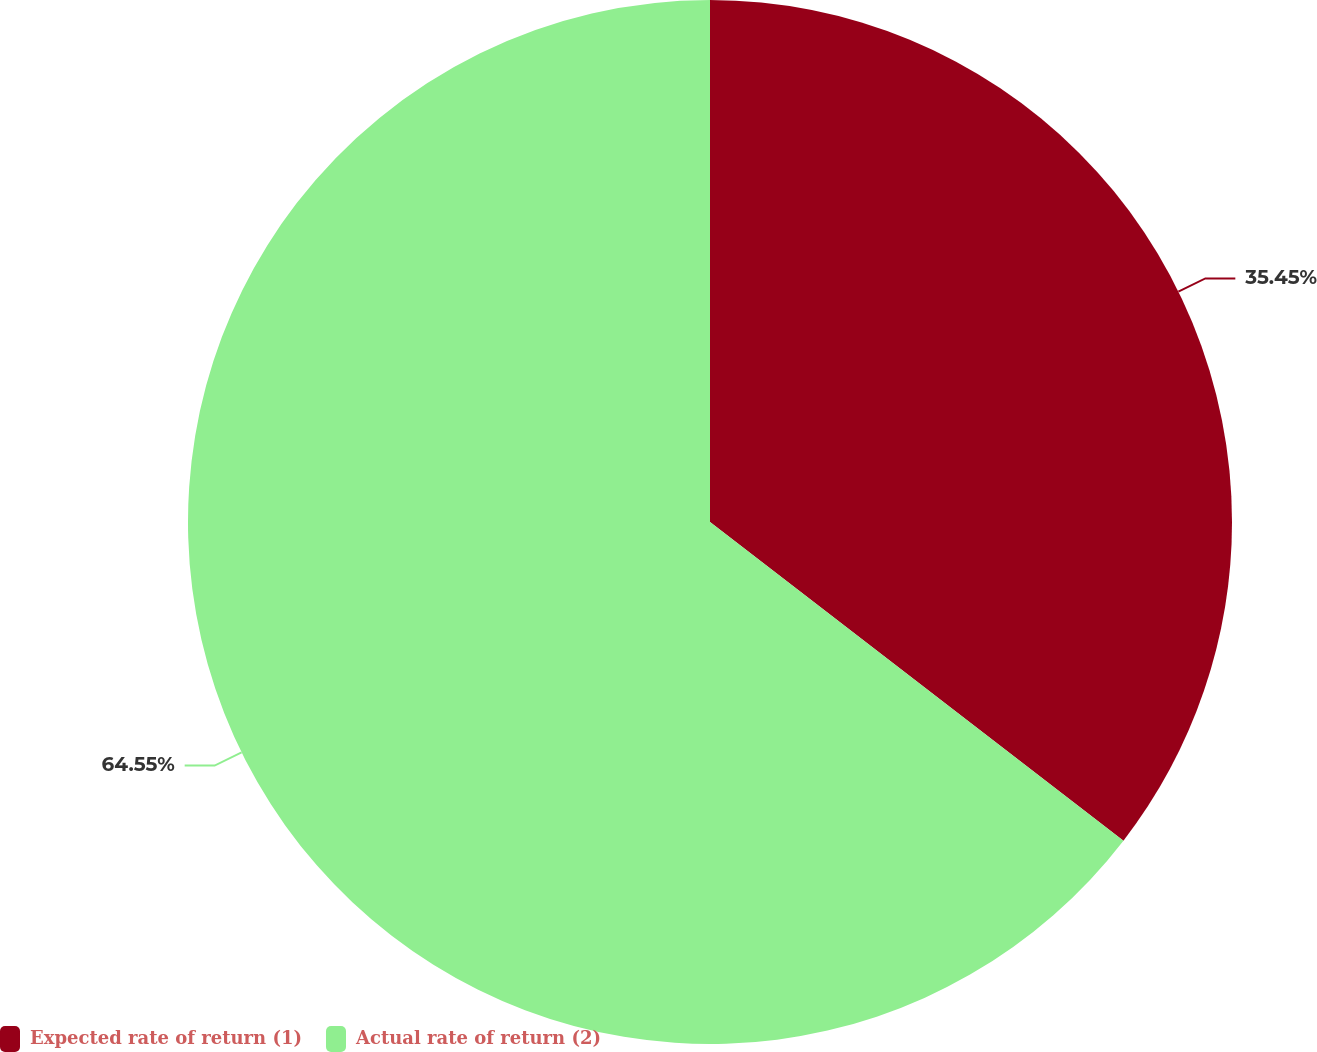<chart> <loc_0><loc_0><loc_500><loc_500><pie_chart><fcel>Expected rate of return (1)<fcel>Actual rate of return (2)<nl><fcel>35.45%<fcel>64.55%<nl></chart> 